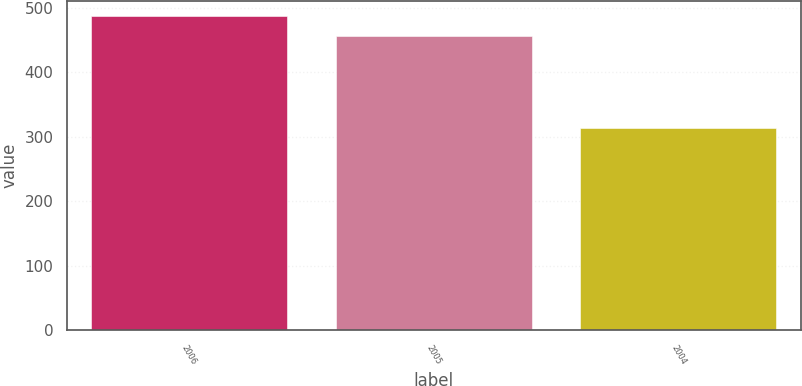<chart> <loc_0><loc_0><loc_500><loc_500><bar_chart><fcel>2006<fcel>2005<fcel>2004<nl><fcel>487<fcel>456<fcel>314<nl></chart> 